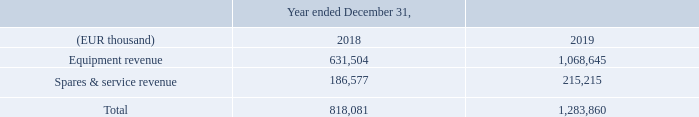Revenue stream
The Company generates revenue primarily from the sales of equipment and sales of spares & service. The products and services described by nature in Note 1, can be part of all revenue streams.
The proceeds resulting from the patent litigation & arbitration settlements (€159 million) are included in the equipment revenue stream.
Where can the products and services described by nature be found? Note 1. What is the  Equipment revenue in 2018?
Answer scale should be: thousand. 631,504. What is the  Spares & service revenue for 2019?
Answer scale should be: thousand. 215,215. What is the patent litigation & arbitration settlements expressed as a percentage of Equipment revenue in 2019?
Answer scale should be: percent. 159 millions / 1,068,645 thousands
Answer: 14.88. What is the change in total revenue from 2018 to 2019?
Answer scale should be: thousand.  1,283,860 - 818,081 
Answer: 465779. What was the component that comprised of the largest proportion of revenue for 2018 and 2019 respectively? Compare whether  Equipment revenue or  Spares & service revenue has a larger value for 2018 and 2019
Answer: equipment revenue, equipment revenue. 